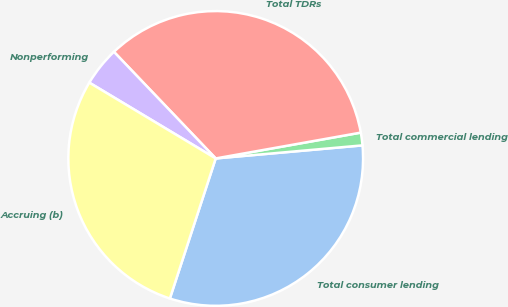<chart> <loc_0><loc_0><loc_500><loc_500><pie_chart><fcel>Total consumer lending<fcel>Total commercial lending<fcel>Total TDRs<fcel>Nonperforming<fcel>Accruing (b)<nl><fcel>31.44%<fcel>1.39%<fcel>34.32%<fcel>4.27%<fcel>28.56%<nl></chart> 